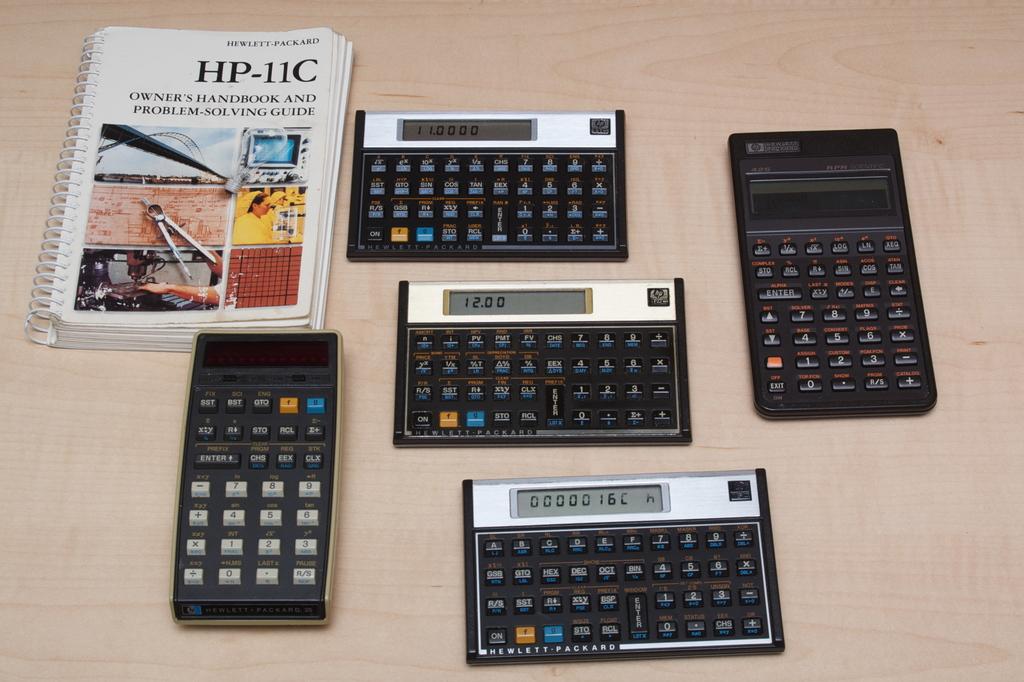Is this a calculus text book?
Ensure brevity in your answer.  No. What number is shown on the middle calculator?
Keep it short and to the point. 12.00. 